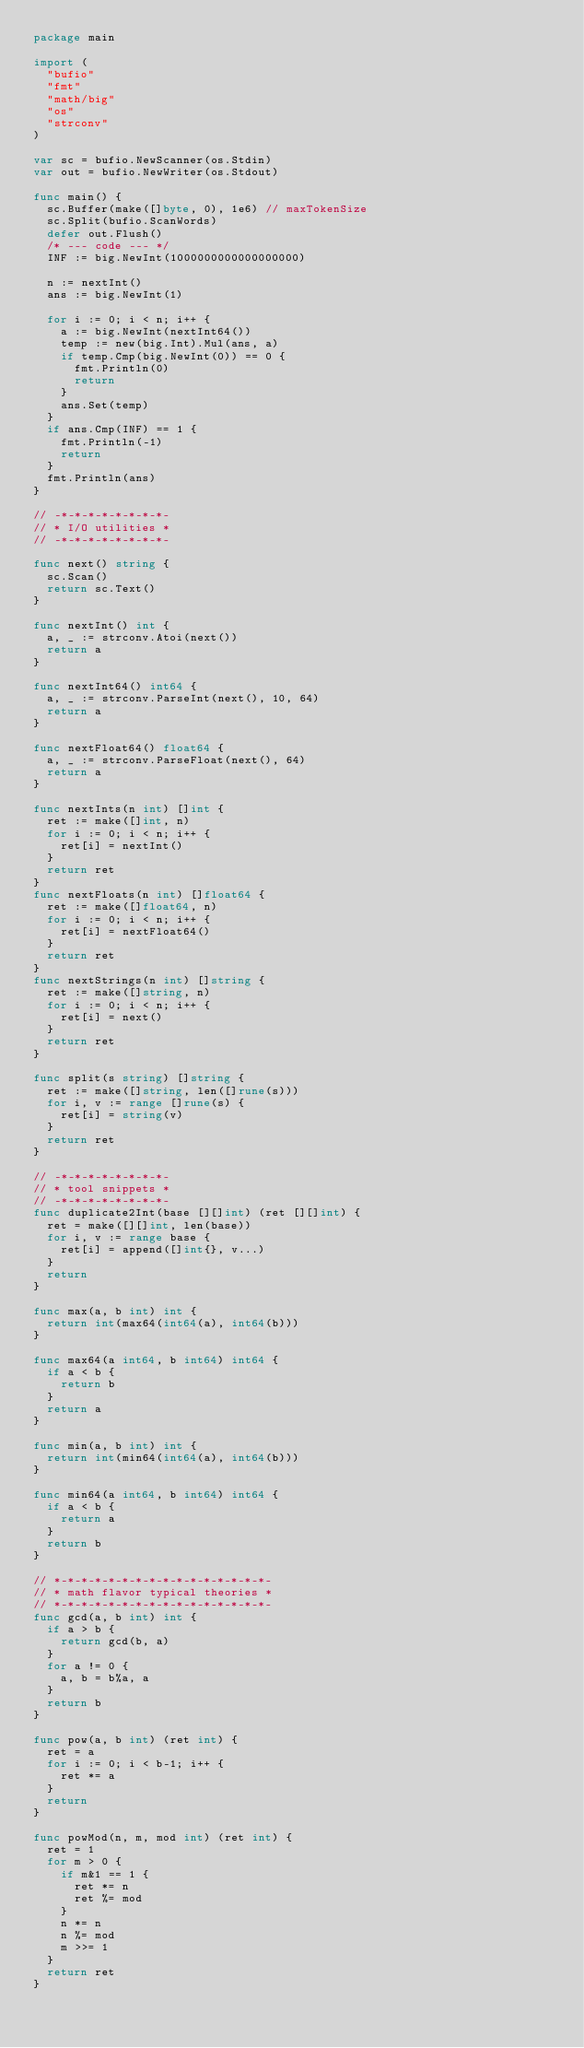<code> <loc_0><loc_0><loc_500><loc_500><_Go_>package main

import (
	"bufio"
	"fmt"
	"math/big"
	"os"
	"strconv"
)

var sc = bufio.NewScanner(os.Stdin)
var out = bufio.NewWriter(os.Stdout)

func main() {
	sc.Buffer(make([]byte, 0), 1e6) // maxTokenSize
	sc.Split(bufio.ScanWords)
	defer out.Flush()
	/* --- code --- */
	INF := big.NewInt(1000000000000000000)

	n := nextInt()
	ans := big.NewInt(1)

	for i := 0; i < n; i++ {
		a := big.NewInt(nextInt64())
		temp := new(big.Int).Mul(ans, a)
		if temp.Cmp(big.NewInt(0)) == 0 {
			fmt.Println(0)
			return
		}
		ans.Set(temp)
	}
	if ans.Cmp(INF) == 1 {
		fmt.Println(-1)
		return
	}
	fmt.Println(ans)
}

// -*-*-*-*-*-*-*-*-
// * I/O utilities *
// -*-*-*-*-*-*-*-*-

func next() string {
	sc.Scan()
	return sc.Text()
}

func nextInt() int {
	a, _ := strconv.Atoi(next())
	return a
}

func nextInt64() int64 {
	a, _ := strconv.ParseInt(next(), 10, 64)
	return a
}

func nextFloat64() float64 {
	a, _ := strconv.ParseFloat(next(), 64)
	return a
}

func nextInts(n int) []int {
	ret := make([]int, n)
	for i := 0; i < n; i++ {
		ret[i] = nextInt()
	}
	return ret
}
func nextFloats(n int) []float64 {
	ret := make([]float64, n)
	for i := 0; i < n; i++ {
		ret[i] = nextFloat64()
	}
	return ret
}
func nextStrings(n int) []string {
	ret := make([]string, n)
	for i := 0; i < n; i++ {
		ret[i] = next()
	}
	return ret
}

func split(s string) []string {
	ret := make([]string, len([]rune(s)))
	for i, v := range []rune(s) {
		ret[i] = string(v)
	}
	return ret
}

// -*-*-*-*-*-*-*-*-
// * tool snippets *
// -*-*-*-*-*-*-*-*-
func duplicate2Int(base [][]int) (ret [][]int) {
	ret = make([][]int, len(base))
	for i, v := range base {
		ret[i] = append([]int{}, v...)
	}
	return
}

func max(a, b int) int {
	return int(max64(int64(a), int64(b)))
}

func max64(a int64, b int64) int64 {
	if a < b {
		return b
	}
	return a
}

func min(a, b int) int {
	return int(min64(int64(a), int64(b)))
}

func min64(a int64, b int64) int64 {
	if a < b {
		return a
	}
	return b
}

// *-*-*-*-*-*-*-*-*-*-*-*-*-*-*-*-
// * math flavor typical theories *
// *-*-*-*-*-*-*-*-*-*-*-*-*-*-*-*-
func gcd(a, b int) int {
	if a > b {
		return gcd(b, a)
	}
	for a != 0 {
		a, b = b%a, a
	}
	return b
}

func pow(a, b int) (ret int) {
	ret = a
	for i := 0; i < b-1; i++ {
		ret *= a
	}
	return
}

func powMod(n, m, mod int) (ret int) {
	ret = 1
	for m > 0 {
		if m&1 == 1 {
			ret *= n
			ret %= mod
		}
		n *= n
		n %= mod
		m >>= 1
	}
	return ret
}
</code> 